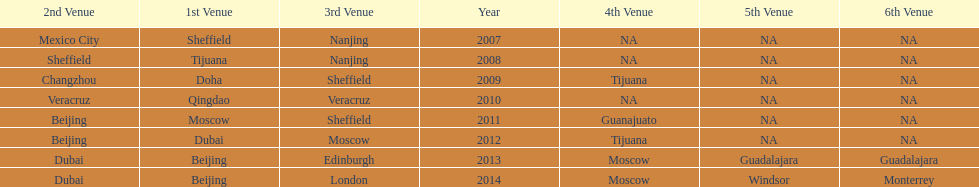What was the last year where tijuana was a venue? 2012. 